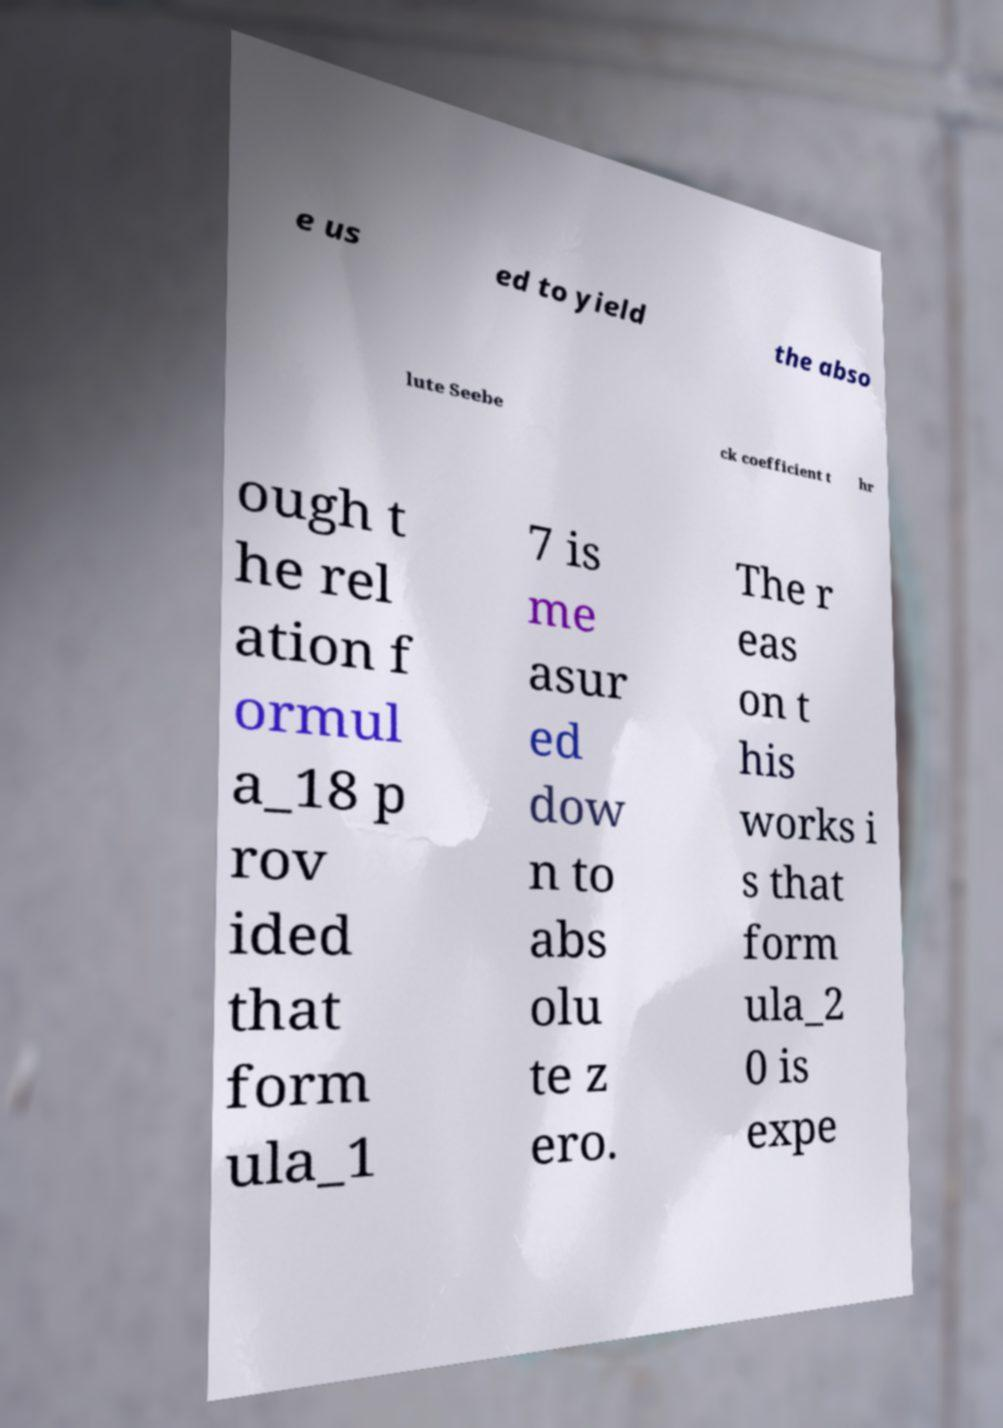For documentation purposes, I need the text within this image transcribed. Could you provide that? e us ed to yield the abso lute Seebe ck coefficient t hr ough t he rel ation f ormul a_18 p rov ided that form ula_1 7 is me asur ed dow n to abs olu te z ero. The r eas on t his works i s that form ula_2 0 is expe 